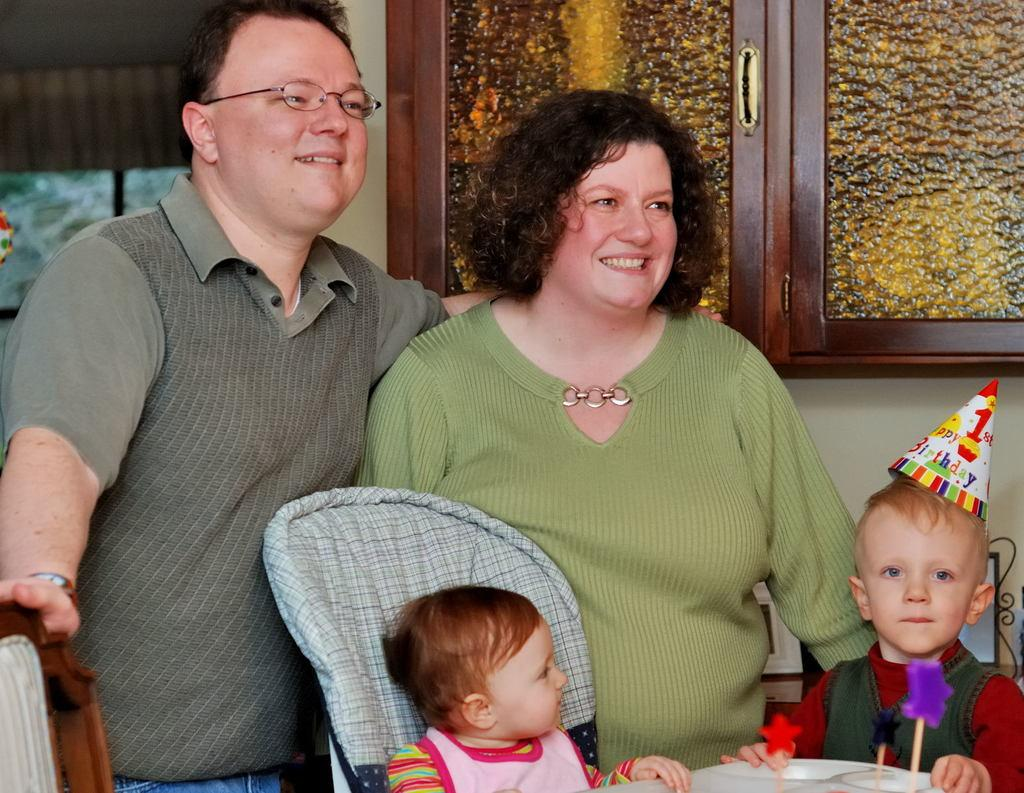How many people are present in the image? There are two people, a man and a woman, present in the image. What are the man and woman doing in the image? The man and woman are standing. How many kids are in the image? There are two kids in the image. What are the kids doing in the image? The kids are sitting on chairs. What can be seen in the background of the image? There are cupboards and a wall in the background of the image. What type of discovery did the woman make while using the rake in the image? There is no rake present in the image, and therefore no discovery can be made. 